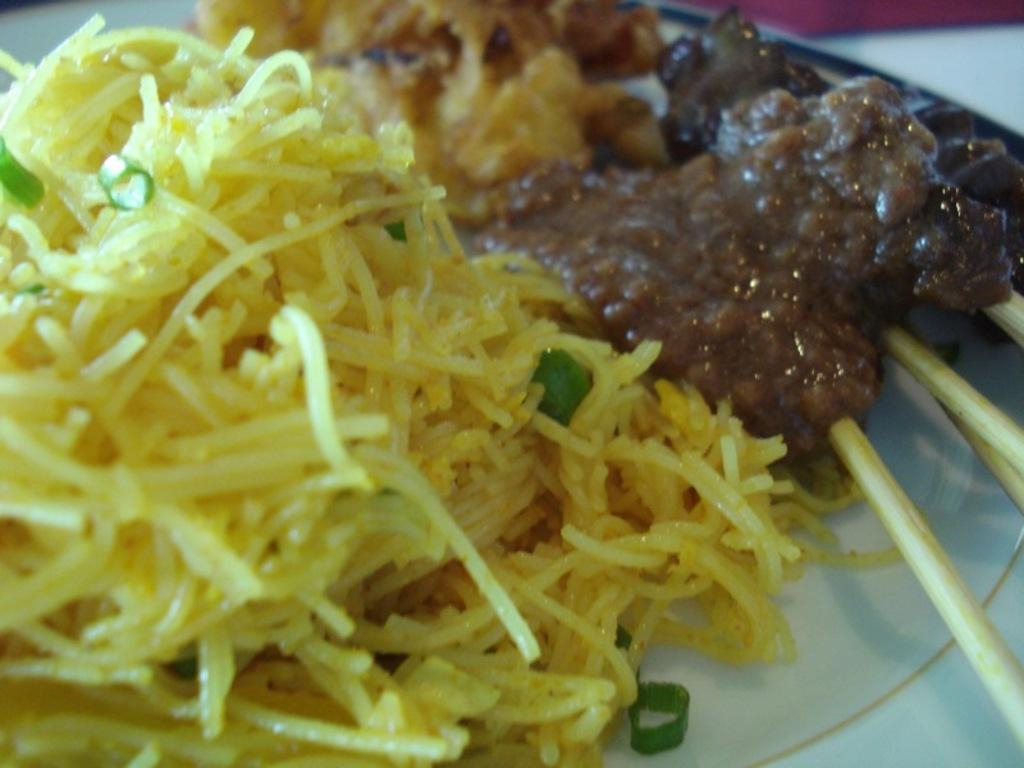What is present on the plate in the image? There is food on the plate in the image. What type of border can be seen around the food on the plate? There is no border visible around the food on the plate in the image. 